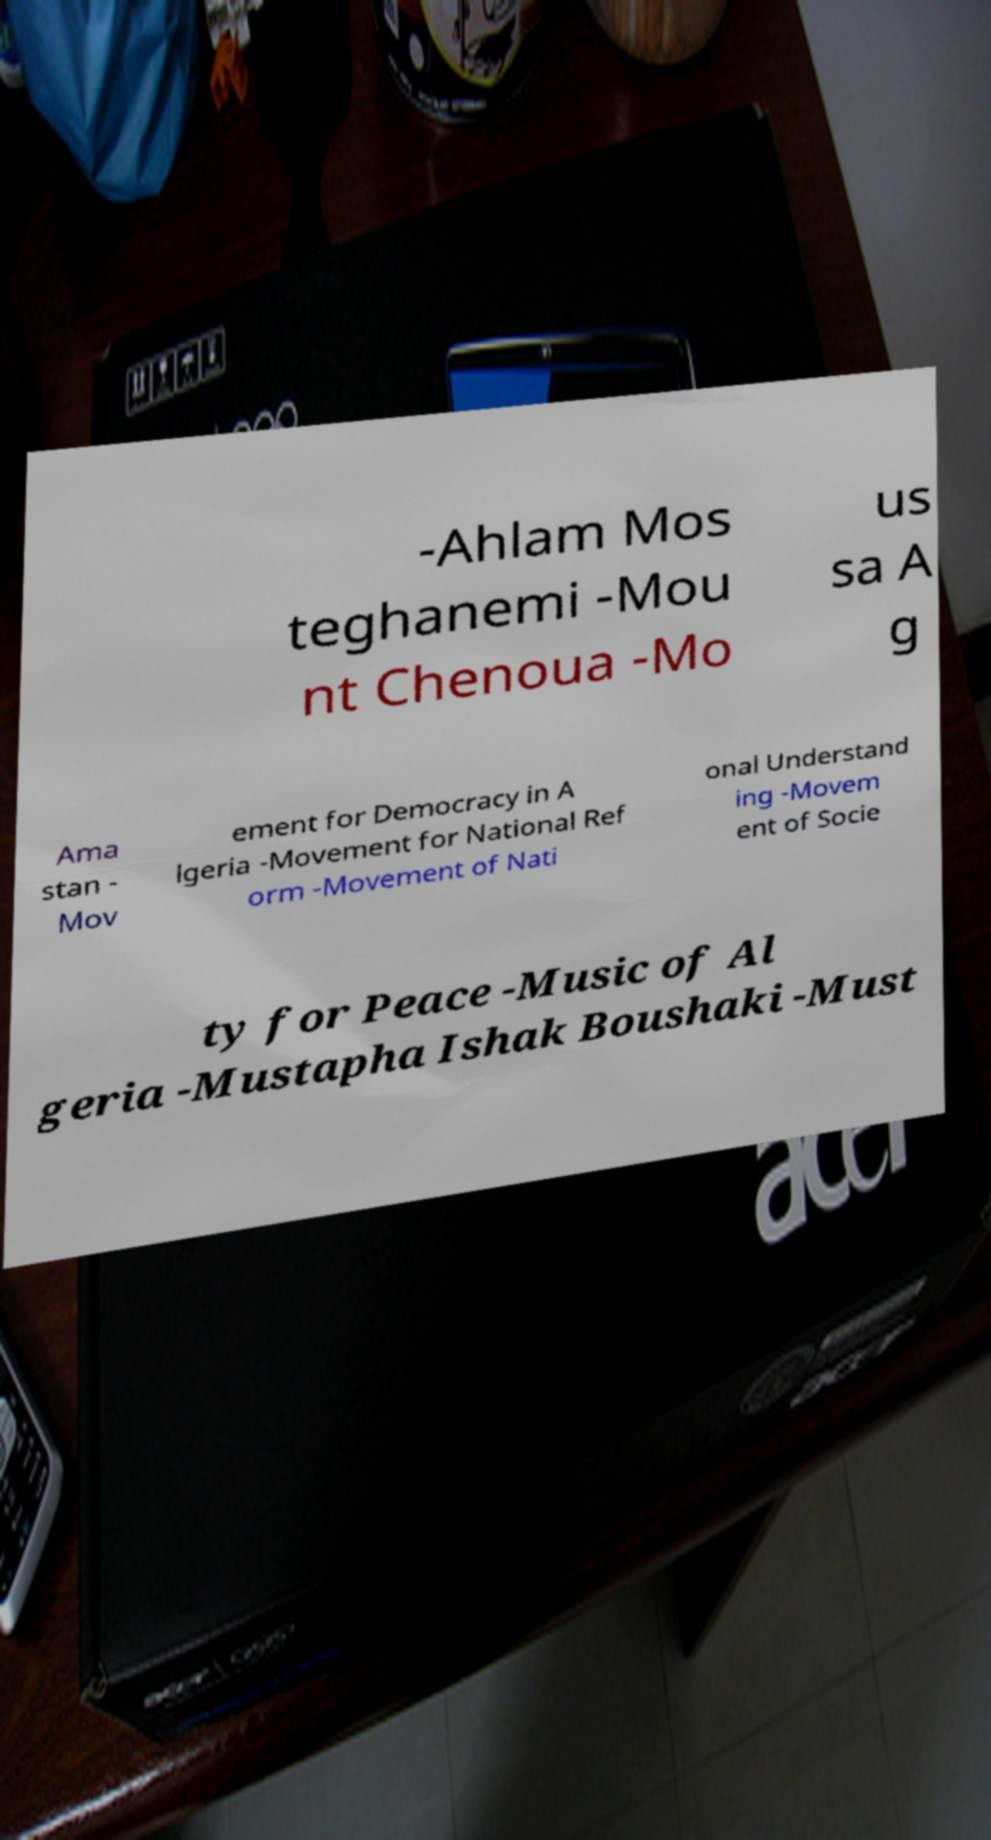What messages or text are displayed in this image? I need them in a readable, typed format. -Ahlam Mos teghanemi -Mou nt Chenoua -Mo us sa A g Ama stan - Mov ement for Democracy in A lgeria -Movement for National Ref orm -Movement of Nati onal Understand ing -Movem ent of Socie ty for Peace -Music of Al geria -Mustapha Ishak Boushaki -Must 